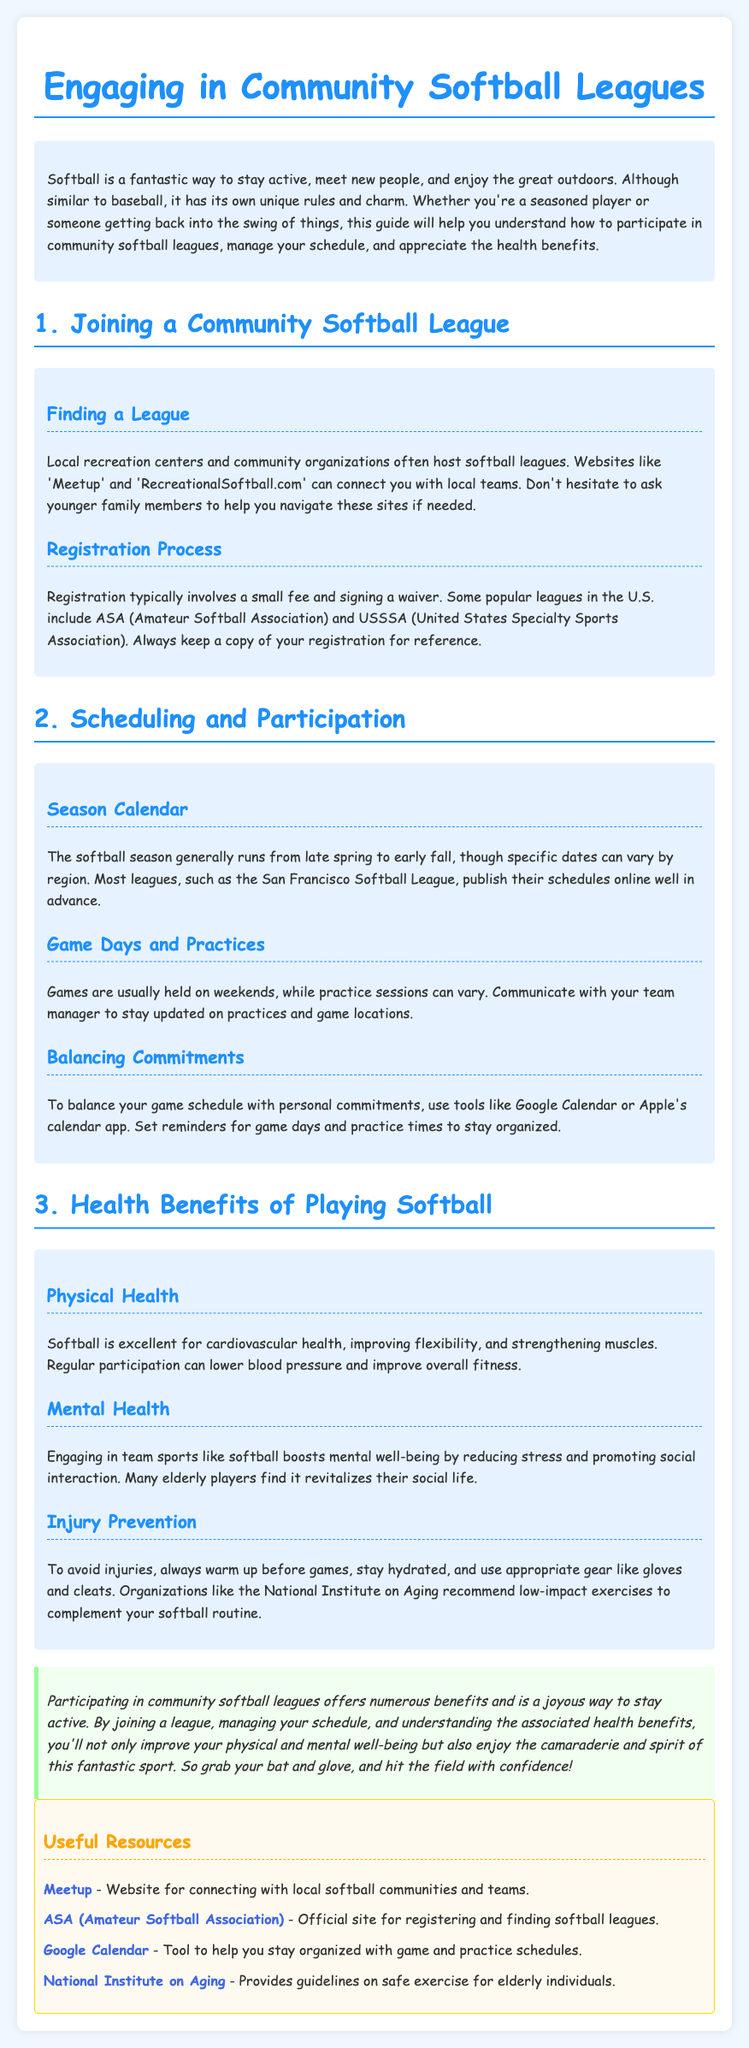What season does the softball league generally run? The document states that the softball season generally runs from late spring to early fall.
Answer: late spring to early fall What is a website to connect with local softball teams? The document mentions 'Meetup' and 'RecreationalSoftball.com' as websites to connect with local teams.
Answer: Meetup What do you need to keep a copy of after registration? The document advises to always keep a copy of your registration for reference.
Answer: registration How is softball beneficial for mental health? The document explains that engaging in team sports like softball boosts mental well-being by reducing stress and promoting social interaction.
Answer: reducing stress What tool can be used to help manage game schedules? The document suggests using Google Calendar or Apple's calendar app for managing game schedules.
Answer: Google Calendar Which associations are mentioned for registration? The document mentions ASA (Amateur Softball Association) and USSSA (United States Specialty Sports Association) for registration.
Answer: ASA and USSSA What should players do to avoid injuries? The document advises to always warm up before games to avoid injuries.
Answer: warm up What color is the background of the conclusion section? The document describes the conclusion section's background color as light green.
Answer: light green 